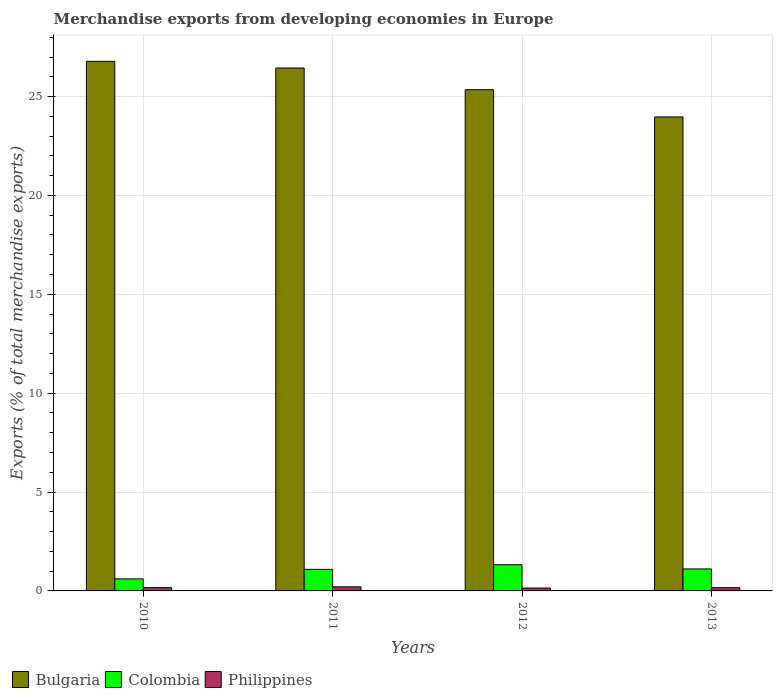How many different coloured bars are there?
Provide a short and direct response. 3. How many groups of bars are there?
Provide a succinct answer. 4. Are the number of bars on each tick of the X-axis equal?
Provide a succinct answer. Yes. How many bars are there on the 4th tick from the left?
Ensure brevity in your answer.  3. In how many cases, is the number of bars for a given year not equal to the number of legend labels?
Give a very brief answer. 0. What is the percentage of total merchandise exports in Philippines in 2012?
Offer a very short reply. 0.15. Across all years, what is the maximum percentage of total merchandise exports in Philippines?
Ensure brevity in your answer.  0.21. Across all years, what is the minimum percentage of total merchandise exports in Philippines?
Offer a very short reply. 0.15. In which year was the percentage of total merchandise exports in Bulgaria maximum?
Ensure brevity in your answer.  2010. In which year was the percentage of total merchandise exports in Philippines minimum?
Ensure brevity in your answer.  2012. What is the total percentage of total merchandise exports in Colombia in the graph?
Provide a succinct answer. 4.14. What is the difference between the percentage of total merchandise exports in Bulgaria in 2011 and that in 2013?
Your response must be concise. 2.47. What is the difference between the percentage of total merchandise exports in Bulgaria in 2011 and the percentage of total merchandise exports in Colombia in 2013?
Make the answer very short. 25.33. What is the average percentage of total merchandise exports in Philippines per year?
Your response must be concise. 0.17. In the year 2011, what is the difference between the percentage of total merchandise exports in Bulgaria and percentage of total merchandise exports in Philippines?
Your answer should be compact. 26.24. In how many years, is the percentage of total merchandise exports in Philippines greater than 16 %?
Your answer should be compact. 0. What is the ratio of the percentage of total merchandise exports in Philippines in 2011 to that in 2013?
Your answer should be compact. 1.26. Is the percentage of total merchandise exports in Colombia in 2011 less than that in 2013?
Your answer should be compact. Yes. What is the difference between the highest and the second highest percentage of total merchandise exports in Colombia?
Your answer should be compact. 0.21. What is the difference between the highest and the lowest percentage of total merchandise exports in Colombia?
Provide a short and direct response. 0.71. In how many years, is the percentage of total merchandise exports in Bulgaria greater than the average percentage of total merchandise exports in Bulgaria taken over all years?
Give a very brief answer. 2. Is the sum of the percentage of total merchandise exports in Philippines in 2011 and 2012 greater than the maximum percentage of total merchandise exports in Colombia across all years?
Your response must be concise. No. What does the 2nd bar from the left in 2011 represents?
Offer a terse response. Colombia. What does the 3rd bar from the right in 2010 represents?
Give a very brief answer. Bulgaria. How many bars are there?
Your answer should be very brief. 12. What is the difference between two consecutive major ticks on the Y-axis?
Give a very brief answer. 5. Does the graph contain any zero values?
Your answer should be very brief. No. How many legend labels are there?
Give a very brief answer. 3. How are the legend labels stacked?
Keep it short and to the point. Horizontal. What is the title of the graph?
Make the answer very short. Merchandise exports from developing economies in Europe. Does "Kosovo" appear as one of the legend labels in the graph?
Give a very brief answer. No. What is the label or title of the X-axis?
Keep it short and to the point. Years. What is the label or title of the Y-axis?
Offer a terse response. Exports (% of total merchandise exports). What is the Exports (% of total merchandise exports) of Bulgaria in 2010?
Your response must be concise. 26.78. What is the Exports (% of total merchandise exports) of Colombia in 2010?
Provide a succinct answer. 0.61. What is the Exports (% of total merchandise exports) of Philippines in 2010?
Your answer should be compact. 0.17. What is the Exports (% of total merchandise exports) of Bulgaria in 2011?
Your answer should be very brief. 26.44. What is the Exports (% of total merchandise exports) in Colombia in 2011?
Keep it short and to the point. 1.09. What is the Exports (% of total merchandise exports) of Philippines in 2011?
Provide a succinct answer. 0.21. What is the Exports (% of total merchandise exports) in Bulgaria in 2012?
Your response must be concise. 25.35. What is the Exports (% of total merchandise exports) of Colombia in 2012?
Provide a short and direct response. 1.32. What is the Exports (% of total merchandise exports) of Philippines in 2012?
Your answer should be very brief. 0.15. What is the Exports (% of total merchandise exports) of Bulgaria in 2013?
Your answer should be compact. 23.97. What is the Exports (% of total merchandise exports) in Colombia in 2013?
Provide a short and direct response. 1.11. What is the Exports (% of total merchandise exports) of Philippines in 2013?
Make the answer very short. 0.16. Across all years, what is the maximum Exports (% of total merchandise exports) of Bulgaria?
Your answer should be compact. 26.78. Across all years, what is the maximum Exports (% of total merchandise exports) of Colombia?
Your answer should be very brief. 1.32. Across all years, what is the maximum Exports (% of total merchandise exports) in Philippines?
Your response must be concise. 0.21. Across all years, what is the minimum Exports (% of total merchandise exports) in Bulgaria?
Offer a very short reply. 23.97. Across all years, what is the minimum Exports (% of total merchandise exports) of Colombia?
Offer a very short reply. 0.61. Across all years, what is the minimum Exports (% of total merchandise exports) in Philippines?
Ensure brevity in your answer.  0.15. What is the total Exports (% of total merchandise exports) of Bulgaria in the graph?
Keep it short and to the point. 102.54. What is the total Exports (% of total merchandise exports) in Colombia in the graph?
Provide a succinct answer. 4.14. What is the total Exports (% of total merchandise exports) in Philippines in the graph?
Make the answer very short. 0.68. What is the difference between the Exports (% of total merchandise exports) in Bulgaria in 2010 and that in 2011?
Offer a very short reply. 0.34. What is the difference between the Exports (% of total merchandise exports) in Colombia in 2010 and that in 2011?
Offer a very short reply. -0.48. What is the difference between the Exports (% of total merchandise exports) of Philippines in 2010 and that in 2011?
Your answer should be very brief. -0.04. What is the difference between the Exports (% of total merchandise exports) in Bulgaria in 2010 and that in 2012?
Make the answer very short. 1.43. What is the difference between the Exports (% of total merchandise exports) in Colombia in 2010 and that in 2012?
Ensure brevity in your answer.  -0.71. What is the difference between the Exports (% of total merchandise exports) of Philippines in 2010 and that in 2012?
Your answer should be very brief. 0.02. What is the difference between the Exports (% of total merchandise exports) in Bulgaria in 2010 and that in 2013?
Keep it short and to the point. 2.81. What is the difference between the Exports (% of total merchandise exports) of Colombia in 2010 and that in 2013?
Your response must be concise. -0.5. What is the difference between the Exports (% of total merchandise exports) of Philippines in 2010 and that in 2013?
Your answer should be very brief. 0. What is the difference between the Exports (% of total merchandise exports) in Bulgaria in 2011 and that in 2012?
Keep it short and to the point. 1.1. What is the difference between the Exports (% of total merchandise exports) of Colombia in 2011 and that in 2012?
Your answer should be compact. -0.23. What is the difference between the Exports (% of total merchandise exports) in Philippines in 2011 and that in 2012?
Ensure brevity in your answer.  0.06. What is the difference between the Exports (% of total merchandise exports) of Bulgaria in 2011 and that in 2013?
Your answer should be compact. 2.47. What is the difference between the Exports (% of total merchandise exports) of Colombia in 2011 and that in 2013?
Offer a very short reply. -0.02. What is the difference between the Exports (% of total merchandise exports) of Philippines in 2011 and that in 2013?
Give a very brief answer. 0.04. What is the difference between the Exports (% of total merchandise exports) in Bulgaria in 2012 and that in 2013?
Your answer should be very brief. 1.38. What is the difference between the Exports (% of total merchandise exports) of Colombia in 2012 and that in 2013?
Your response must be concise. 0.21. What is the difference between the Exports (% of total merchandise exports) in Philippines in 2012 and that in 2013?
Offer a very short reply. -0.02. What is the difference between the Exports (% of total merchandise exports) of Bulgaria in 2010 and the Exports (% of total merchandise exports) of Colombia in 2011?
Provide a short and direct response. 25.69. What is the difference between the Exports (% of total merchandise exports) in Bulgaria in 2010 and the Exports (% of total merchandise exports) in Philippines in 2011?
Your answer should be compact. 26.57. What is the difference between the Exports (% of total merchandise exports) of Colombia in 2010 and the Exports (% of total merchandise exports) of Philippines in 2011?
Your answer should be very brief. 0.4. What is the difference between the Exports (% of total merchandise exports) of Bulgaria in 2010 and the Exports (% of total merchandise exports) of Colombia in 2012?
Your response must be concise. 25.46. What is the difference between the Exports (% of total merchandise exports) in Bulgaria in 2010 and the Exports (% of total merchandise exports) in Philippines in 2012?
Offer a very short reply. 26.63. What is the difference between the Exports (% of total merchandise exports) in Colombia in 2010 and the Exports (% of total merchandise exports) in Philippines in 2012?
Your response must be concise. 0.46. What is the difference between the Exports (% of total merchandise exports) in Bulgaria in 2010 and the Exports (% of total merchandise exports) in Colombia in 2013?
Keep it short and to the point. 25.67. What is the difference between the Exports (% of total merchandise exports) of Bulgaria in 2010 and the Exports (% of total merchandise exports) of Philippines in 2013?
Provide a succinct answer. 26.62. What is the difference between the Exports (% of total merchandise exports) in Colombia in 2010 and the Exports (% of total merchandise exports) in Philippines in 2013?
Your answer should be very brief. 0.45. What is the difference between the Exports (% of total merchandise exports) in Bulgaria in 2011 and the Exports (% of total merchandise exports) in Colombia in 2012?
Provide a short and direct response. 25.12. What is the difference between the Exports (% of total merchandise exports) in Bulgaria in 2011 and the Exports (% of total merchandise exports) in Philippines in 2012?
Give a very brief answer. 26.3. What is the difference between the Exports (% of total merchandise exports) of Colombia in 2011 and the Exports (% of total merchandise exports) of Philippines in 2012?
Provide a short and direct response. 0.94. What is the difference between the Exports (% of total merchandise exports) of Bulgaria in 2011 and the Exports (% of total merchandise exports) of Colombia in 2013?
Offer a very short reply. 25.33. What is the difference between the Exports (% of total merchandise exports) in Bulgaria in 2011 and the Exports (% of total merchandise exports) in Philippines in 2013?
Make the answer very short. 26.28. What is the difference between the Exports (% of total merchandise exports) of Colombia in 2011 and the Exports (% of total merchandise exports) of Philippines in 2013?
Offer a very short reply. 0.93. What is the difference between the Exports (% of total merchandise exports) in Bulgaria in 2012 and the Exports (% of total merchandise exports) in Colombia in 2013?
Provide a short and direct response. 24.24. What is the difference between the Exports (% of total merchandise exports) in Bulgaria in 2012 and the Exports (% of total merchandise exports) in Philippines in 2013?
Ensure brevity in your answer.  25.18. What is the difference between the Exports (% of total merchandise exports) in Colombia in 2012 and the Exports (% of total merchandise exports) in Philippines in 2013?
Provide a succinct answer. 1.16. What is the average Exports (% of total merchandise exports) of Bulgaria per year?
Offer a terse response. 25.64. What is the average Exports (% of total merchandise exports) of Colombia per year?
Make the answer very short. 1.03. What is the average Exports (% of total merchandise exports) in Philippines per year?
Provide a short and direct response. 0.17. In the year 2010, what is the difference between the Exports (% of total merchandise exports) of Bulgaria and Exports (% of total merchandise exports) of Colombia?
Provide a succinct answer. 26.17. In the year 2010, what is the difference between the Exports (% of total merchandise exports) of Bulgaria and Exports (% of total merchandise exports) of Philippines?
Provide a succinct answer. 26.61. In the year 2010, what is the difference between the Exports (% of total merchandise exports) of Colombia and Exports (% of total merchandise exports) of Philippines?
Your answer should be compact. 0.44. In the year 2011, what is the difference between the Exports (% of total merchandise exports) in Bulgaria and Exports (% of total merchandise exports) in Colombia?
Your response must be concise. 25.35. In the year 2011, what is the difference between the Exports (% of total merchandise exports) of Bulgaria and Exports (% of total merchandise exports) of Philippines?
Provide a short and direct response. 26.24. In the year 2011, what is the difference between the Exports (% of total merchandise exports) of Colombia and Exports (% of total merchandise exports) of Philippines?
Keep it short and to the point. 0.88. In the year 2012, what is the difference between the Exports (% of total merchandise exports) in Bulgaria and Exports (% of total merchandise exports) in Colombia?
Ensure brevity in your answer.  24.02. In the year 2012, what is the difference between the Exports (% of total merchandise exports) in Bulgaria and Exports (% of total merchandise exports) in Philippines?
Your response must be concise. 25.2. In the year 2012, what is the difference between the Exports (% of total merchandise exports) of Colombia and Exports (% of total merchandise exports) of Philippines?
Offer a very short reply. 1.18. In the year 2013, what is the difference between the Exports (% of total merchandise exports) of Bulgaria and Exports (% of total merchandise exports) of Colombia?
Offer a very short reply. 22.86. In the year 2013, what is the difference between the Exports (% of total merchandise exports) of Bulgaria and Exports (% of total merchandise exports) of Philippines?
Provide a succinct answer. 23.81. In the year 2013, what is the difference between the Exports (% of total merchandise exports) in Colombia and Exports (% of total merchandise exports) in Philippines?
Your response must be concise. 0.95. What is the ratio of the Exports (% of total merchandise exports) in Bulgaria in 2010 to that in 2011?
Your answer should be compact. 1.01. What is the ratio of the Exports (% of total merchandise exports) in Colombia in 2010 to that in 2011?
Provide a succinct answer. 0.56. What is the ratio of the Exports (% of total merchandise exports) in Philippines in 2010 to that in 2011?
Your answer should be very brief. 0.8. What is the ratio of the Exports (% of total merchandise exports) in Bulgaria in 2010 to that in 2012?
Provide a succinct answer. 1.06. What is the ratio of the Exports (% of total merchandise exports) in Colombia in 2010 to that in 2012?
Provide a short and direct response. 0.46. What is the ratio of the Exports (% of total merchandise exports) in Philippines in 2010 to that in 2012?
Provide a short and direct response. 1.13. What is the ratio of the Exports (% of total merchandise exports) of Bulgaria in 2010 to that in 2013?
Offer a very short reply. 1.12. What is the ratio of the Exports (% of total merchandise exports) in Colombia in 2010 to that in 2013?
Your answer should be very brief. 0.55. What is the ratio of the Exports (% of total merchandise exports) of Philippines in 2010 to that in 2013?
Make the answer very short. 1.02. What is the ratio of the Exports (% of total merchandise exports) in Bulgaria in 2011 to that in 2012?
Offer a very short reply. 1.04. What is the ratio of the Exports (% of total merchandise exports) of Colombia in 2011 to that in 2012?
Provide a short and direct response. 0.82. What is the ratio of the Exports (% of total merchandise exports) of Philippines in 2011 to that in 2012?
Offer a terse response. 1.41. What is the ratio of the Exports (% of total merchandise exports) of Bulgaria in 2011 to that in 2013?
Your answer should be very brief. 1.1. What is the ratio of the Exports (% of total merchandise exports) in Colombia in 2011 to that in 2013?
Ensure brevity in your answer.  0.98. What is the ratio of the Exports (% of total merchandise exports) of Philippines in 2011 to that in 2013?
Ensure brevity in your answer.  1.26. What is the ratio of the Exports (% of total merchandise exports) in Bulgaria in 2012 to that in 2013?
Offer a terse response. 1.06. What is the ratio of the Exports (% of total merchandise exports) of Colombia in 2012 to that in 2013?
Give a very brief answer. 1.19. What is the ratio of the Exports (% of total merchandise exports) of Philippines in 2012 to that in 2013?
Ensure brevity in your answer.  0.9. What is the difference between the highest and the second highest Exports (% of total merchandise exports) of Bulgaria?
Keep it short and to the point. 0.34. What is the difference between the highest and the second highest Exports (% of total merchandise exports) of Colombia?
Your response must be concise. 0.21. What is the difference between the highest and the second highest Exports (% of total merchandise exports) of Philippines?
Make the answer very short. 0.04. What is the difference between the highest and the lowest Exports (% of total merchandise exports) in Bulgaria?
Provide a short and direct response. 2.81. What is the difference between the highest and the lowest Exports (% of total merchandise exports) of Colombia?
Your response must be concise. 0.71. What is the difference between the highest and the lowest Exports (% of total merchandise exports) of Philippines?
Your response must be concise. 0.06. 